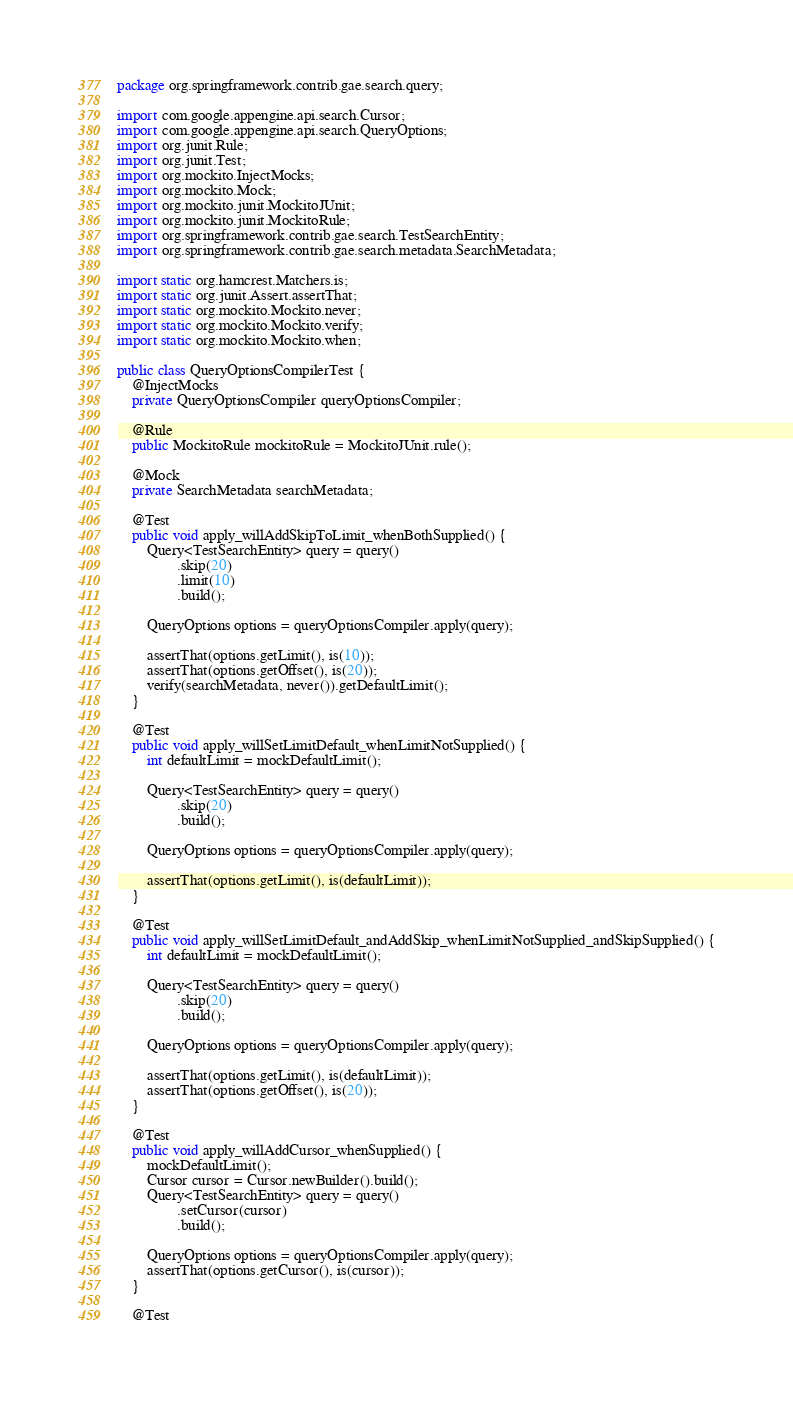<code> <loc_0><loc_0><loc_500><loc_500><_Java_>package org.springframework.contrib.gae.search.query;

import com.google.appengine.api.search.Cursor;
import com.google.appengine.api.search.QueryOptions;
import org.junit.Rule;
import org.junit.Test;
import org.mockito.InjectMocks;
import org.mockito.Mock;
import org.mockito.junit.MockitoJUnit;
import org.mockito.junit.MockitoRule;
import org.springframework.contrib.gae.search.TestSearchEntity;
import org.springframework.contrib.gae.search.metadata.SearchMetadata;

import static org.hamcrest.Matchers.is;
import static org.junit.Assert.assertThat;
import static org.mockito.Mockito.never;
import static org.mockito.Mockito.verify;
import static org.mockito.Mockito.when;

public class QueryOptionsCompilerTest {
    @InjectMocks
    private QueryOptionsCompiler queryOptionsCompiler;

    @Rule
    public MockitoRule mockitoRule = MockitoJUnit.rule();

    @Mock
    private SearchMetadata searchMetadata;

    @Test
    public void apply_willAddSkipToLimit_whenBothSupplied() {
        Query<TestSearchEntity> query = query()
                .skip(20)
                .limit(10)
                .build();

        QueryOptions options = queryOptionsCompiler.apply(query);

        assertThat(options.getLimit(), is(10));
        assertThat(options.getOffset(), is(20));
        verify(searchMetadata, never()).getDefaultLimit();
    }

    @Test
    public void apply_willSetLimitDefault_whenLimitNotSupplied() {
        int defaultLimit = mockDefaultLimit();

        Query<TestSearchEntity> query = query()
                .skip(20)
                .build();

        QueryOptions options = queryOptionsCompiler.apply(query);

        assertThat(options.getLimit(), is(defaultLimit));
    }

    @Test
    public void apply_willSetLimitDefault_andAddSkip_whenLimitNotSupplied_andSkipSupplied() {
        int defaultLimit = mockDefaultLimit();

        Query<TestSearchEntity> query = query()
                .skip(20)
                .build();

        QueryOptions options = queryOptionsCompiler.apply(query);

        assertThat(options.getLimit(), is(defaultLimit));
        assertThat(options.getOffset(), is(20));
    }

    @Test
    public void apply_willAddCursor_whenSupplied() {
        mockDefaultLimit();
        Cursor cursor = Cursor.newBuilder().build();
        Query<TestSearchEntity> query = query()
                .setCursor(cursor)
                .build();

        QueryOptions options = queryOptionsCompiler.apply(query);
        assertThat(options.getCursor(), is(cursor));
    }

    @Test</code> 